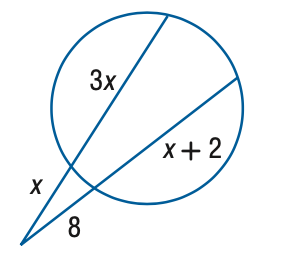Question: Find x to the nearest tenth. 
Choices:
A. 4
B. 5.6
C. 6
D. 8
Answer with the letter. Answer: B 